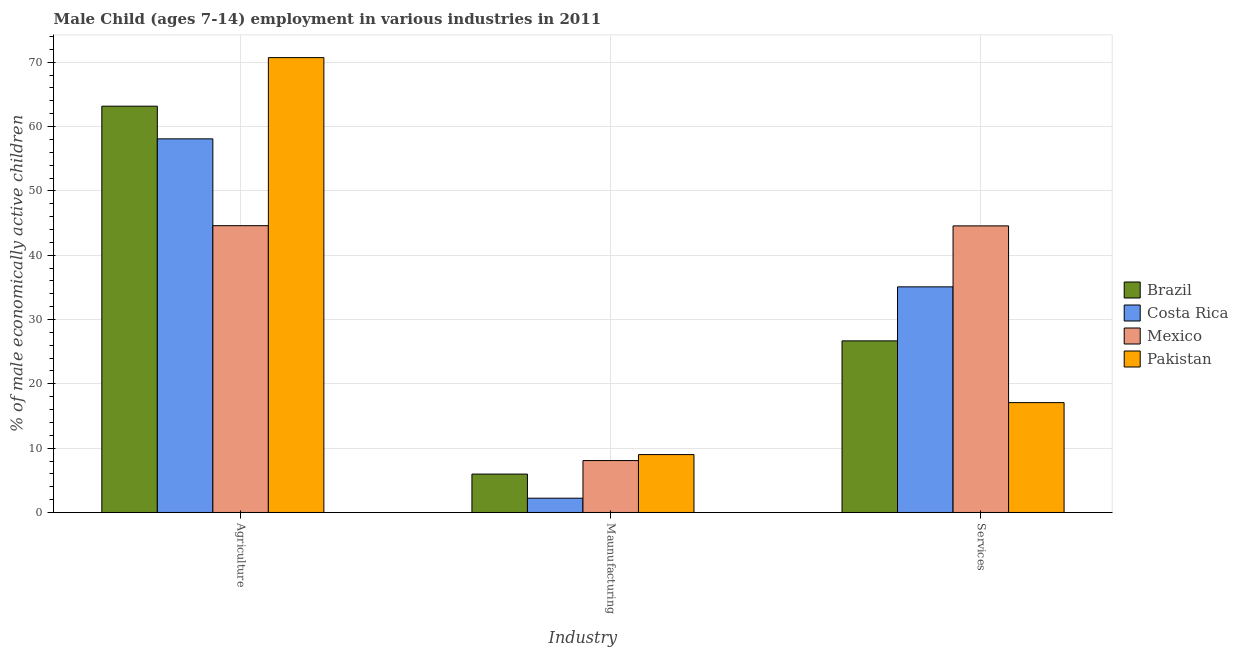How many groups of bars are there?
Give a very brief answer. 3. How many bars are there on the 2nd tick from the left?
Ensure brevity in your answer.  4. How many bars are there on the 2nd tick from the right?
Offer a very short reply. 4. What is the label of the 3rd group of bars from the left?
Keep it short and to the point. Services. What is the percentage of economically active children in manufacturing in Brazil?
Keep it short and to the point. 5.97. Across all countries, what is the minimum percentage of economically active children in services?
Give a very brief answer. 17.08. In which country was the percentage of economically active children in agriculture maximum?
Provide a succinct answer. Pakistan. In which country was the percentage of economically active children in manufacturing minimum?
Offer a terse response. Costa Rica. What is the total percentage of economically active children in services in the graph?
Offer a terse response. 123.4. What is the difference between the percentage of economically active children in manufacturing in Mexico and that in Costa Rica?
Ensure brevity in your answer.  5.85. What is the difference between the percentage of economically active children in manufacturing in Mexico and the percentage of economically active children in services in Brazil?
Keep it short and to the point. -18.61. What is the average percentage of economically active children in services per country?
Provide a succinct answer. 30.85. What is the difference between the percentage of economically active children in agriculture and percentage of economically active children in manufacturing in Brazil?
Offer a terse response. 57.2. In how many countries, is the percentage of economically active children in manufacturing greater than 6 %?
Offer a very short reply. 2. What is the ratio of the percentage of economically active children in manufacturing in Pakistan to that in Mexico?
Give a very brief answer. 1.12. Is the percentage of economically active children in services in Costa Rica less than that in Pakistan?
Your response must be concise. No. What is the difference between the highest and the second highest percentage of economically active children in agriculture?
Your answer should be compact. 7.55. What is the difference between the highest and the lowest percentage of economically active children in manufacturing?
Provide a succinct answer. 6.78. Is the sum of the percentage of economically active children in services in Pakistan and Costa Rica greater than the maximum percentage of economically active children in manufacturing across all countries?
Ensure brevity in your answer.  Yes. What does the 2nd bar from the right in Agriculture represents?
Give a very brief answer. Mexico. Is it the case that in every country, the sum of the percentage of economically active children in agriculture and percentage of economically active children in manufacturing is greater than the percentage of economically active children in services?
Provide a short and direct response. Yes. Are all the bars in the graph horizontal?
Offer a terse response. No. What is the difference between two consecutive major ticks on the Y-axis?
Keep it short and to the point. 10. Are the values on the major ticks of Y-axis written in scientific E-notation?
Your response must be concise. No. Does the graph contain any zero values?
Ensure brevity in your answer.  No. Does the graph contain grids?
Give a very brief answer. Yes. How many legend labels are there?
Give a very brief answer. 4. How are the legend labels stacked?
Offer a terse response. Vertical. What is the title of the graph?
Provide a short and direct response. Male Child (ages 7-14) employment in various industries in 2011. What is the label or title of the X-axis?
Give a very brief answer. Industry. What is the label or title of the Y-axis?
Keep it short and to the point. % of male economically active children. What is the % of male economically active children in Brazil in Agriculture?
Offer a very short reply. 63.17. What is the % of male economically active children in Costa Rica in Agriculture?
Your answer should be compact. 58.09. What is the % of male economically active children of Mexico in Agriculture?
Offer a terse response. 44.59. What is the % of male economically active children of Pakistan in Agriculture?
Provide a short and direct response. 70.72. What is the % of male economically active children in Brazil in Maunufacturing?
Your response must be concise. 5.97. What is the % of male economically active children in Costa Rica in Maunufacturing?
Your answer should be very brief. 2.22. What is the % of male economically active children in Mexico in Maunufacturing?
Your answer should be compact. 8.07. What is the % of male economically active children of Brazil in Services?
Give a very brief answer. 26.68. What is the % of male economically active children in Costa Rica in Services?
Keep it short and to the point. 35.08. What is the % of male economically active children in Mexico in Services?
Provide a succinct answer. 44.56. What is the % of male economically active children in Pakistan in Services?
Offer a terse response. 17.08. Across all Industry, what is the maximum % of male economically active children in Brazil?
Your response must be concise. 63.17. Across all Industry, what is the maximum % of male economically active children in Costa Rica?
Your answer should be very brief. 58.09. Across all Industry, what is the maximum % of male economically active children of Mexico?
Provide a succinct answer. 44.59. Across all Industry, what is the maximum % of male economically active children of Pakistan?
Provide a succinct answer. 70.72. Across all Industry, what is the minimum % of male economically active children in Brazil?
Offer a terse response. 5.97. Across all Industry, what is the minimum % of male economically active children of Costa Rica?
Ensure brevity in your answer.  2.22. Across all Industry, what is the minimum % of male economically active children in Mexico?
Provide a succinct answer. 8.07. Across all Industry, what is the minimum % of male economically active children of Pakistan?
Provide a short and direct response. 9. What is the total % of male economically active children in Brazil in the graph?
Give a very brief answer. 95.82. What is the total % of male economically active children of Costa Rica in the graph?
Give a very brief answer. 95.39. What is the total % of male economically active children in Mexico in the graph?
Your answer should be very brief. 97.22. What is the total % of male economically active children of Pakistan in the graph?
Ensure brevity in your answer.  96.8. What is the difference between the % of male economically active children in Brazil in Agriculture and that in Maunufacturing?
Offer a terse response. 57.2. What is the difference between the % of male economically active children in Costa Rica in Agriculture and that in Maunufacturing?
Provide a succinct answer. 55.87. What is the difference between the % of male economically active children in Mexico in Agriculture and that in Maunufacturing?
Make the answer very short. 36.52. What is the difference between the % of male economically active children of Pakistan in Agriculture and that in Maunufacturing?
Offer a terse response. 61.72. What is the difference between the % of male economically active children of Brazil in Agriculture and that in Services?
Your answer should be very brief. 36.49. What is the difference between the % of male economically active children of Costa Rica in Agriculture and that in Services?
Your answer should be compact. 23.01. What is the difference between the % of male economically active children in Pakistan in Agriculture and that in Services?
Ensure brevity in your answer.  53.64. What is the difference between the % of male economically active children in Brazil in Maunufacturing and that in Services?
Give a very brief answer. -20.71. What is the difference between the % of male economically active children in Costa Rica in Maunufacturing and that in Services?
Keep it short and to the point. -32.86. What is the difference between the % of male economically active children of Mexico in Maunufacturing and that in Services?
Your response must be concise. -36.49. What is the difference between the % of male economically active children of Pakistan in Maunufacturing and that in Services?
Provide a short and direct response. -8.08. What is the difference between the % of male economically active children in Brazil in Agriculture and the % of male economically active children in Costa Rica in Maunufacturing?
Provide a succinct answer. 60.95. What is the difference between the % of male economically active children of Brazil in Agriculture and the % of male economically active children of Mexico in Maunufacturing?
Offer a very short reply. 55.1. What is the difference between the % of male economically active children in Brazil in Agriculture and the % of male economically active children in Pakistan in Maunufacturing?
Give a very brief answer. 54.17. What is the difference between the % of male economically active children in Costa Rica in Agriculture and the % of male economically active children in Mexico in Maunufacturing?
Keep it short and to the point. 50.02. What is the difference between the % of male economically active children of Costa Rica in Agriculture and the % of male economically active children of Pakistan in Maunufacturing?
Your response must be concise. 49.09. What is the difference between the % of male economically active children of Mexico in Agriculture and the % of male economically active children of Pakistan in Maunufacturing?
Keep it short and to the point. 35.59. What is the difference between the % of male economically active children of Brazil in Agriculture and the % of male economically active children of Costa Rica in Services?
Your answer should be very brief. 28.09. What is the difference between the % of male economically active children in Brazil in Agriculture and the % of male economically active children in Mexico in Services?
Give a very brief answer. 18.61. What is the difference between the % of male economically active children in Brazil in Agriculture and the % of male economically active children in Pakistan in Services?
Keep it short and to the point. 46.09. What is the difference between the % of male economically active children of Costa Rica in Agriculture and the % of male economically active children of Mexico in Services?
Make the answer very short. 13.53. What is the difference between the % of male economically active children of Costa Rica in Agriculture and the % of male economically active children of Pakistan in Services?
Offer a very short reply. 41.01. What is the difference between the % of male economically active children in Mexico in Agriculture and the % of male economically active children in Pakistan in Services?
Offer a very short reply. 27.51. What is the difference between the % of male economically active children in Brazil in Maunufacturing and the % of male economically active children in Costa Rica in Services?
Offer a very short reply. -29.11. What is the difference between the % of male economically active children of Brazil in Maunufacturing and the % of male economically active children of Mexico in Services?
Make the answer very short. -38.59. What is the difference between the % of male economically active children of Brazil in Maunufacturing and the % of male economically active children of Pakistan in Services?
Your answer should be compact. -11.11. What is the difference between the % of male economically active children of Costa Rica in Maunufacturing and the % of male economically active children of Mexico in Services?
Give a very brief answer. -42.34. What is the difference between the % of male economically active children of Costa Rica in Maunufacturing and the % of male economically active children of Pakistan in Services?
Give a very brief answer. -14.86. What is the difference between the % of male economically active children in Mexico in Maunufacturing and the % of male economically active children in Pakistan in Services?
Offer a terse response. -9.01. What is the average % of male economically active children of Brazil per Industry?
Your answer should be very brief. 31.94. What is the average % of male economically active children in Costa Rica per Industry?
Offer a terse response. 31.8. What is the average % of male economically active children in Mexico per Industry?
Give a very brief answer. 32.41. What is the average % of male economically active children in Pakistan per Industry?
Offer a very short reply. 32.27. What is the difference between the % of male economically active children in Brazil and % of male economically active children in Costa Rica in Agriculture?
Offer a terse response. 5.08. What is the difference between the % of male economically active children in Brazil and % of male economically active children in Mexico in Agriculture?
Provide a short and direct response. 18.58. What is the difference between the % of male economically active children in Brazil and % of male economically active children in Pakistan in Agriculture?
Keep it short and to the point. -7.55. What is the difference between the % of male economically active children of Costa Rica and % of male economically active children of Mexico in Agriculture?
Offer a terse response. 13.5. What is the difference between the % of male economically active children of Costa Rica and % of male economically active children of Pakistan in Agriculture?
Your answer should be very brief. -12.63. What is the difference between the % of male economically active children in Mexico and % of male economically active children in Pakistan in Agriculture?
Ensure brevity in your answer.  -26.13. What is the difference between the % of male economically active children in Brazil and % of male economically active children in Costa Rica in Maunufacturing?
Offer a very short reply. 3.75. What is the difference between the % of male economically active children in Brazil and % of male economically active children in Mexico in Maunufacturing?
Keep it short and to the point. -2.1. What is the difference between the % of male economically active children in Brazil and % of male economically active children in Pakistan in Maunufacturing?
Give a very brief answer. -3.03. What is the difference between the % of male economically active children of Costa Rica and % of male economically active children of Mexico in Maunufacturing?
Offer a very short reply. -5.85. What is the difference between the % of male economically active children of Costa Rica and % of male economically active children of Pakistan in Maunufacturing?
Offer a very short reply. -6.78. What is the difference between the % of male economically active children of Mexico and % of male economically active children of Pakistan in Maunufacturing?
Provide a succinct answer. -0.93. What is the difference between the % of male economically active children in Brazil and % of male economically active children in Costa Rica in Services?
Make the answer very short. -8.4. What is the difference between the % of male economically active children in Brazil and % of male economically active children in Mexico in Services?
Keep it short and to the point. -17.88. What is the difference between the % of male economically active children of Brazil and % of male economically active children of Pakistan in Services?
Make the answer very short. 9.6. What is the difference between the % of male economically active children in Costa Rica and % of male economically active children in Mexico in Services?
Provide a succinct answer. -9.48. What is the difference between the % of male economically active children of Costa Rica and % of male economically active children of Pakistan in Services?
Offer a very short reply. 18. What is the difference between the % of male economically active children of Mexico and % of male economically active children of Pakistan in Services?
Offer a terse response. 27.48. What is the ratio of the % of male economically active children in Brazil in Agriculture to that in Maunufacturing?
Your answer should be compact. 10.58. What is the ratio of the % of male economically active children in Costa Rica in Agriculture to that in Maunufacturing?
Offer a terse response. 26.17. What is the ratio of the % of male economically active children in Mexico in Agriculture to that in Maunufacturing?
Make the answer very short. 5.53. What is the ratio of the % of male economically active children of Pakistan in Agriculture to that in Maunufacturing?
Offer a very short reply. 7.86. What is the ratio of the % of male economically active children of Brazil in Agriculture to that in Services?
Ensure brevity in your answer.  2.37. What is the ratio of the % of male economically active children of Costa Rica in Agriculture to that in Services?
Provide a short and direct response. 1.66. What is the ratio of the % of male economically active children in Mexico in Agriculture to that in Services?
Give a very brief answer. 1. What is the ratio of the % of male economically active children in Pakistan in Agriculture to that in Services?
Offer a very short reply. 4.14. What is the ratio of the % of male economically active children of Brazil in Maunufacturing to that in Services?
Your response must be concise. 0.22. What is the ratio of the % of male economically active children of Costa Rica in Maunufacturing to that in Services?
Give a very brief answer. 0.06. What is the ratio of the % of male economically active children of Mexico in Maunufacturing to that in Services?
Your response must be concise. 0.18. What is the ratio of the % of male economically active children in Pakistan in Maunufacturing to that in Services?
Ensure brevity in your answer.  0.53. What is the difference between the highest and the second highest % of male economically active children in Brazil?
Your answer should be very brief. 36.49. What is the difference between the highest and the second highest % of male economically active children of Costa Rica?
Ensure brevity in your answer.  23.01. What is the difference between the highest and the second highest % of male economically active children of Mexico?
Make the answer very short. 0.03. What is the difference between the highest and the second highest % of male economically active children of Pakistan?
Offer a terse response. 53.64. What is the difference between the highest and the lowest % of male economically active children in Brazil?
Your answer should be compact. 57.2. What is the difference between the highest and the lowest % of male economically active children in Costa Rica?
Your answer should be very brief. 55.87. What is the difference between the highest and the lowest % of male economically active children in Mexico?
Provide a short and direct response. 36.52. What is the difference between the highest and the lowest % of male economically active children in Pakistan?
Make the answer very short. 61.72. 